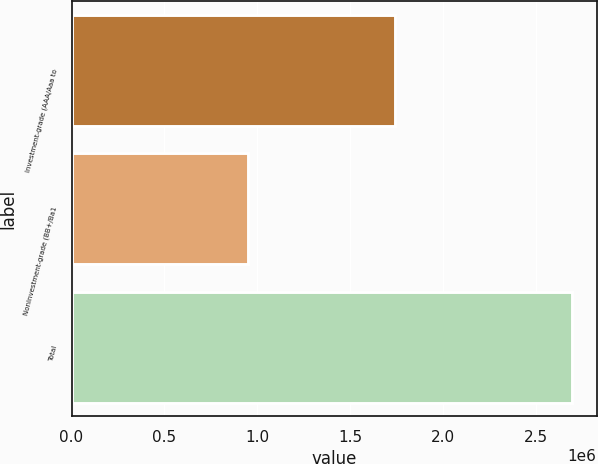<chart> <loc_0><loc_0><loc_500><loc_500><bar_chart><fcel>Investment-grade (AAA/Aaa to<fcel>Noninvestment-grade (BB+/Ba1<fcel>Total<nl><fcel>1.74328e+06<fcel>950619<fcel>2.6939e+06<nl></chart> 